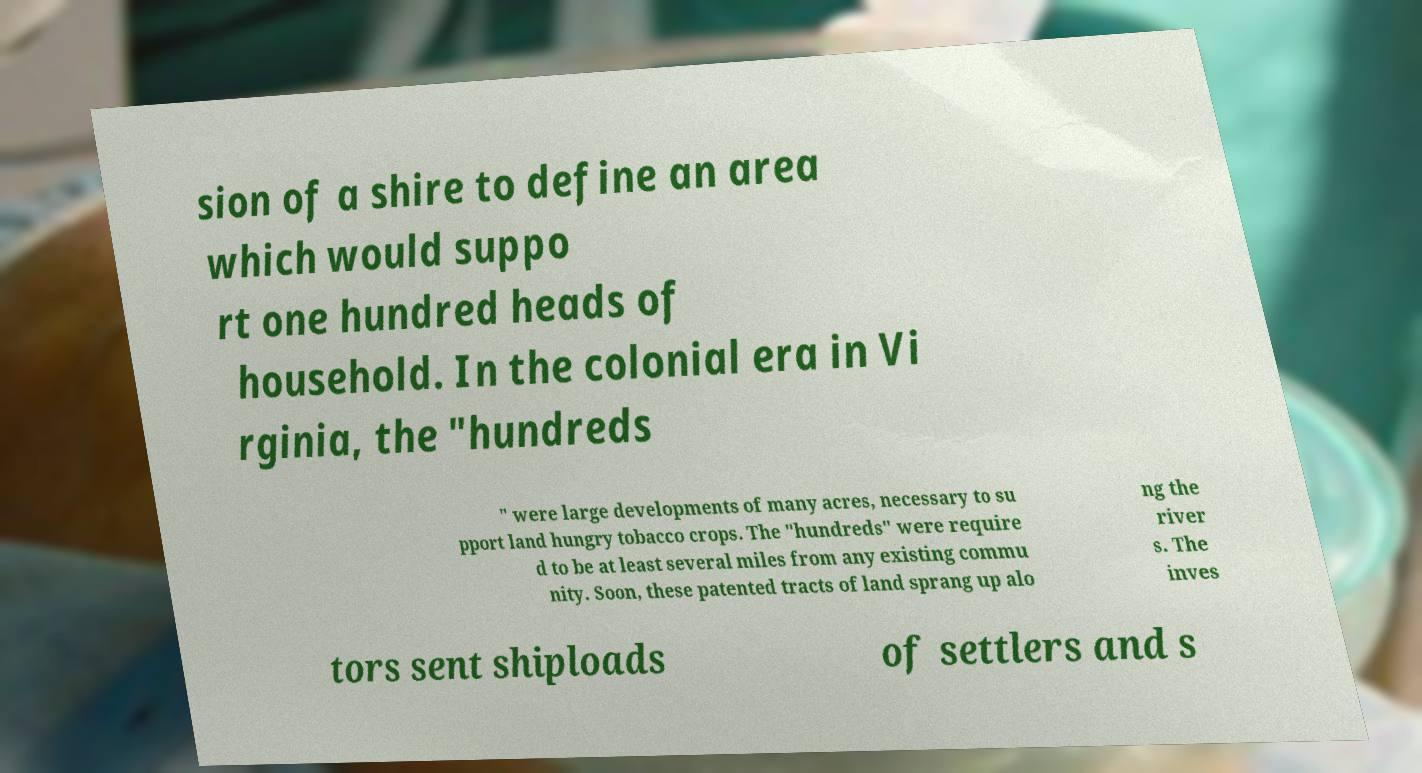For documentation purposes, I need the text within this image transcribed. Could you provide that? sion of a shire to define an area which would suppo rt one hundred heads of household. In the colonial era in Vi rginia, the "hundreds " were large developments of many acres, necessary to su pport land hungry tobacco crops. The "hundreds" were require d to be at least several miles from any existing commu nity. Soon, these patented tracts of land sprang up alo ng the river s. The inves tors sent shiploads of settlers and s 